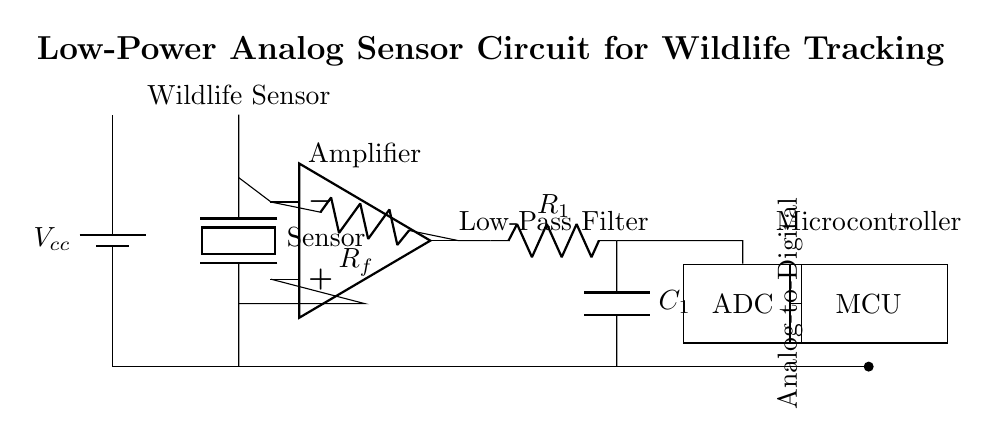What is the main sensor type used in this circuit? The main sensor type is a piezoelectric sensor, which is indicated in the circuit as "Sensor".
Answer: Piezoelectric What voltage source is used in the circuit? The circuit employs a battery as the voltage source, labeled as Vcc in the diagram.
Answer: Vcc What component is used to amplify the sensor signal? The operational amplifier, labeled as "Amplifier", is the component that amplifies the sensor signal.
Answer: Operational amplifier How many resistors are present in the circuit? There are two resistors in the circuit: Rf (feedback resistor) and R1 (in the low-pass filter).
Answer: Two What is the purpose of the low-pass filter in this circuit? The low-pass filter, which consists of a resistor and a capacitor, is used to eliminate high-frequency noise from the sensor signal, allowing only low-frequency signals to pass through.
Answer: Noise reduction What type of device is indicated by the abbreviation "MCU"? The abbreviation "MCU" represents a microcontroller, responsible for processing the signal from the ADC.
Answer: Microcontroller 